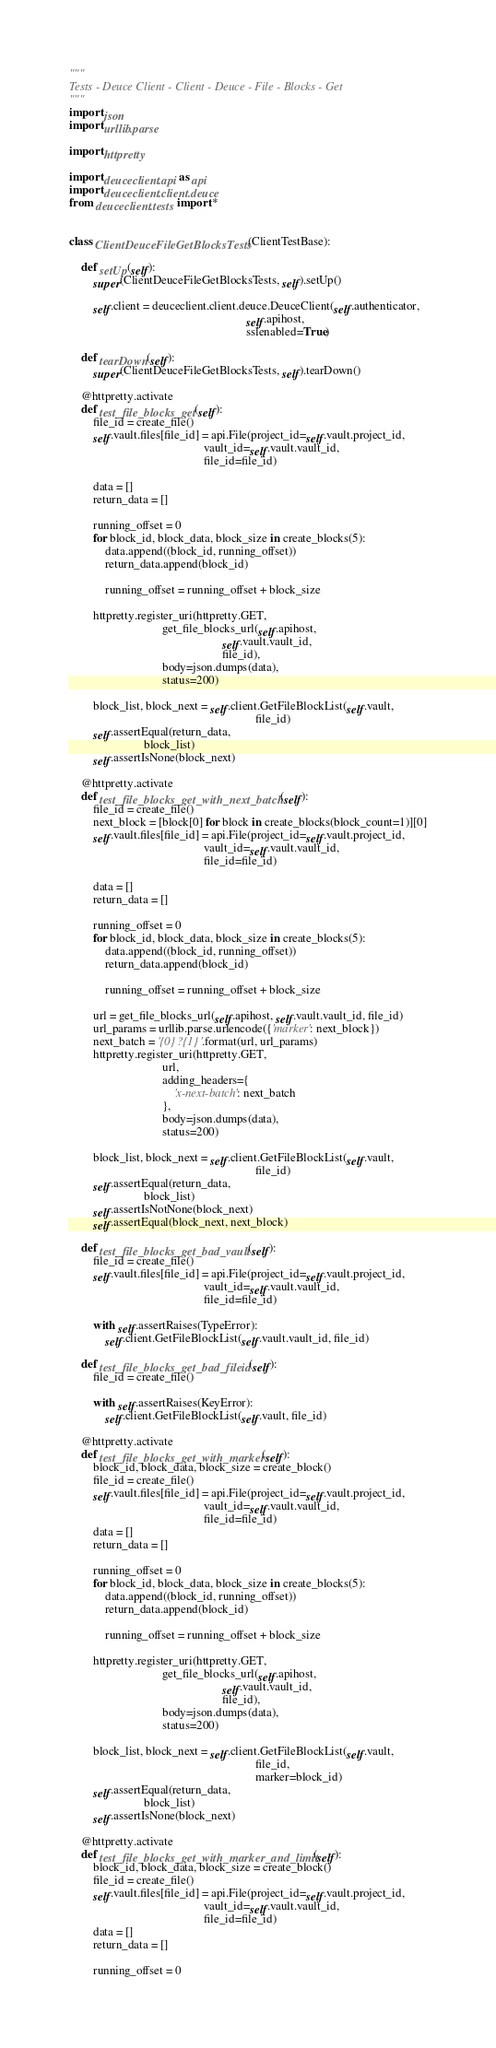Convert code to text. <code><loc_0><loc_0><loc_500><loc_500><_Python_>"""
Tests - Deuce Client - Client - Deuce - File - Blocks - Get
"""
import json
import urllib.parse

import httpretty

import deuceclient.api as api
import deuceclient.client.deuce
from deuceclient.tests import *


class ClientDeuceFileGetBlocksTests(ClientTestBase):

    def setUp(self):
        super(ClientDeuceFileGetBlocksTests, self).setUp()

        self.client = deuceclient.client.deuce.DeuceClient(self.authenticator,
                                                           self.apihost,
                                                           sslenabled=True)

    def tearDown(self):
        super(ClientDeuceFileGetBlocksTests, self).tearDown()

    @httpretty.activate
    def test_file_blocks_get(self):
        file_id = create_file()
        self.vault.files[file_id] = api.File(project_id=self.vault.project_id,
                                             vault_id=self.vault.vault_id,
                                             file_id=file_id)

        data = []
        return_data = []

        running_offset = 0
        for block_id, block_data, block_size in create_blocks(5):
            data.append((block_id, running_offset))
            return_data.append(block_id)

            running_offset = running_offset + block_size

        httpretty.register_uri(httpretty.GET,
                               get_file_blocks_url(self.apihost,
                                                   self.vault.vault_id,
                                                   file_id),
                               body=json.dumps(data),
                               status=200)

        block_list, block_next = self.client.GetFileBlockList(self.vault,
                                                              file_id)
        self.assertEqual(return_data,
                         block_list)
        self.assertIsNone(block_next)

    @httpretty.activate
    def test_file_blocks_get_with_next_batch(self):
        file_id = create_file()
        next_block = [block[0] for block in create_blocks(block_count=1)][0]
        self.vault.files[file_id] = api.File(project_id=self.vault.project_id,
                                             vault_id=self.vault.vault_id,
                                             file_id=file_id)

        data = []
        return_data = []

        running_offset = 0
        for block_id, block_data, block_size in create_blocks(5):
            data.append((block_id, running_offset))
            return_data.append(block_id)

            running_offset = running_offset + block_size

        url = get_file_blocks_url(self.apihost, self.vault.vault_id, file_id)
        url_params = urllib.parse.urlencode({'marker': next_block})
        next_batch = '{0}?{1}'.format(url, url_params)
        httpretty.register_uri(httpretty.GET,
                               url,
                               adding_headers={
                                   'x-next-batch': next_batch
                               },
                               body=json.dumps(data),
                               status=200)

        block_list, block_next = self.client.GetFileBlockList(self.vault,
                                                              file_id)
        self.assertEqual(return_data,
                         block_list)
        self.assertIsNotNone(block_next)
        self.assertEqual(block_next, next_block)

    def test_file_blocks_get_bad_vault(self):
        file_id = create_file()
        self.vault.files[file_id] = api.File(project_id=self.vault.project_id,
                                             vault_id=self.vault.vault_id,
                                             file_id=file_id)

        with self.assertRaises(TypeError):
            self.client.GetFileBlockList(self.vault.vault_id, file_id)

    def test_file_blocks_get_bad_fileid(self):
        file_id = create_file()

        with self.assertRaises(KeyError):
            self.client.GetFileBlockList(self.vault, file_id)

    @httpretty.activate
    def test_file_blocks_get_with_marker(self):
        block_id, block_data, block_size = create_block()
        file_id = create_file()
        self.vault.files[file_id] = api.File(project_id=self.vault.project_id,
                                             vault_id=self.vault.vault_id,
                                             file_id=file_id)
        data = []
        return_data = []

        running_offset = 0
        for block_id, block_data, block_size in create_blocks(5):
            data.append((block_id, running_offset))
            return_data.append(block_id)

            running_offset = running_offset + block_size

        httpretty.register_uri(httpretty.GET,
                               get_file_blocks_url(self.apihost,
                                                   self.vault.vault_id,
                                                   file_id),
                               body=json.dumps(data),
                               status=200)

        block_list, block_next = self.client.GetFileBlockList(self.vault,
                                                              file_id,
                                                              marker=block_id)
        self.assertEqual(return_data,
                         block_list)
        self.assertIsNone(block_next)

    @httpretty.activate
    def test_file_blocks_get_with_marker_and_limit(self):
        block_id, block_data, block_size = create_block()
        file_id = create_file()
        self.vault.files[file_id] = api.File(project_id=self.vault.project_id,
                                             vault_id=self.vault.vault_id,
                                             file_id=file_id)
        data = []
        return_data = []

        running_offset = 0</code> 